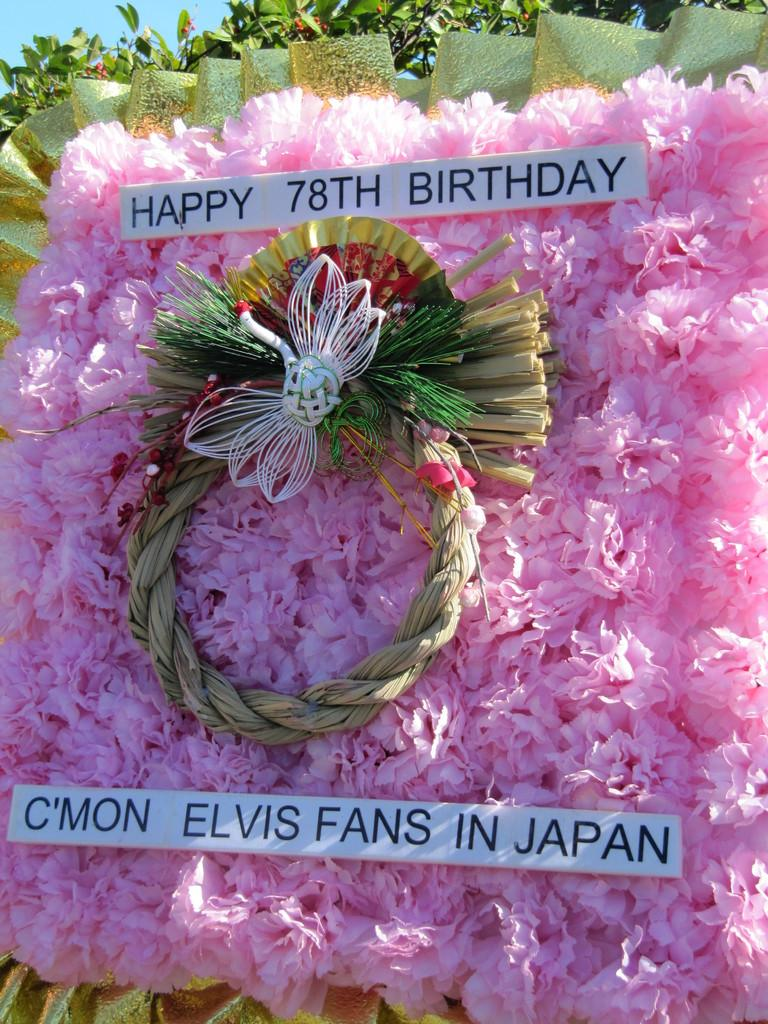What type of flowers are present in the image? There are paper flowers in pink color in the image. What event is being celebrated, as indicated by the board? The board says "78th birthday," so it appears that a 78th birthday is being celebrated. What other natural elements can be seen in the image? There are leaves visible in the image. What is the texture of the cabbage in the image? There is no cabbage present in the image. 